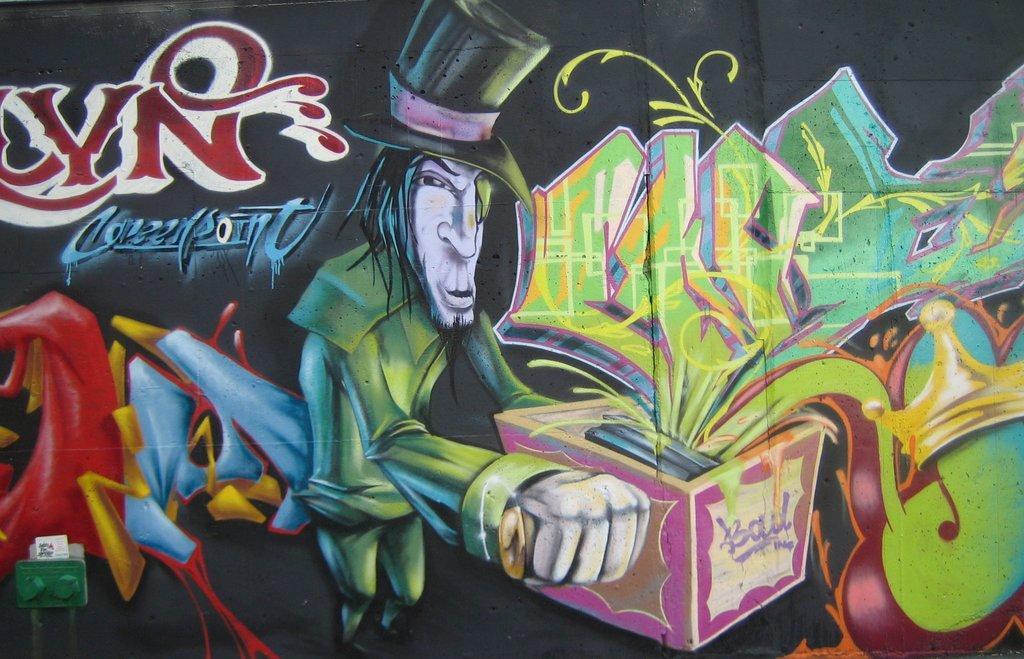Can you describe this image briefly? In the picture we can see a painting of a cartoon man, he is wearing a green dress with a hat which is black in color and holding some box and gifts coming out of that box. 